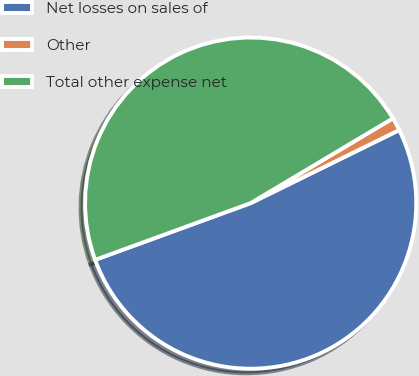<chart> <loc_0><loc_0><loc_500><loc_500><pie_chart><fcel>Net losses on sales of<fcel>Other<fcel>Total other expense net<nl><fcel>51.71%<fcel>1.28%<fcel>47.01%<nl></chart> 